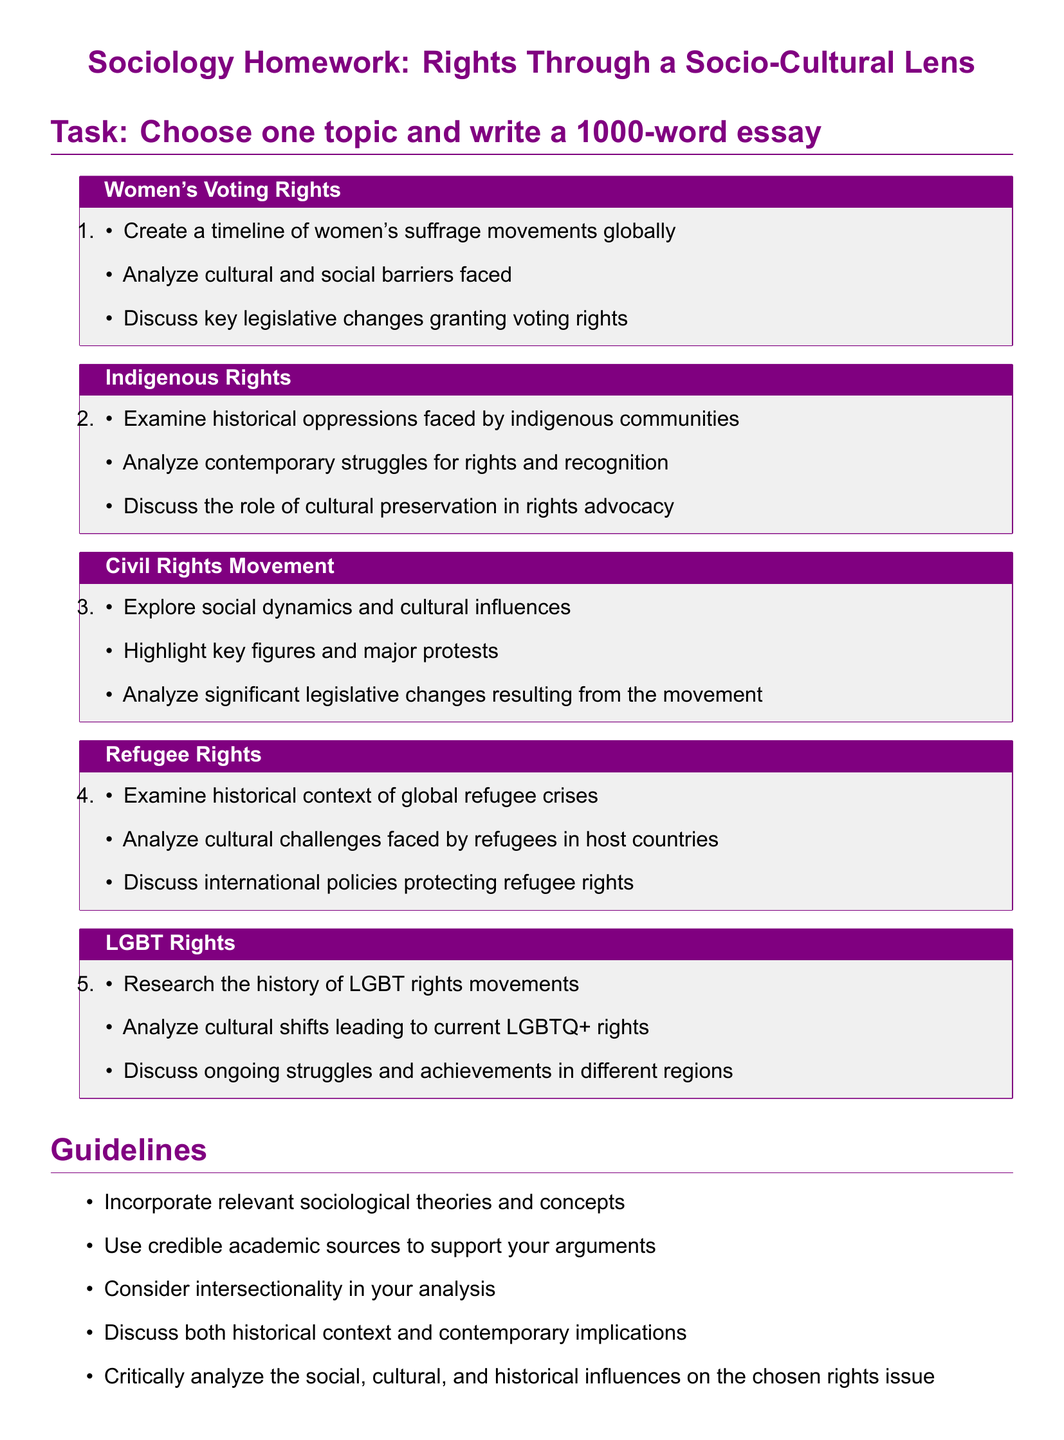What is the title of the homework? The title of the homework is presented at the top of the document, specifying the focus on sociology and rights.
Answer: Sociology Homework: Rights Through a Socio-Cultural Lens How many topics are available for selection in the homework? The document lists the number of topics that students can choose from to write their essays.
Answer: Five What is one of the specific goals of the Women's Voting Rights topic? The document outlines particular objectives for the essays, which include creating a timeline of women's suffrage movements globally.
Answer: Create a timeline of women's suffrage movements globally Which sociological approach should be considered in the analysis? The homework guidelines emphasize the importance of a specific analytical perspective important for understanding complex issues.
Answer: Intersectionality What is the required essay length? The homework indicates a specific word count requirement for the essays to be written by students.
Answer: 1000 words What type of citation style is specified for the submissions? The document provides guidelines on how references should be formatted in the submitted essays.
Answer: APA citation style In which section are the submission details found? The submission details are clearly marked within the document, indicating where students can find necessary information for their submissions.
Answer: Submission Details What color is used for section titles in the document? The document describes the color scheme used for various elements, including section headings, enhancing visual appeal.
Answer: Sociologypurple 